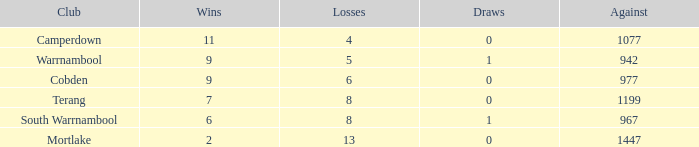When the losses for mortlake surpassed 5, what was the count of draws? 1.0. 